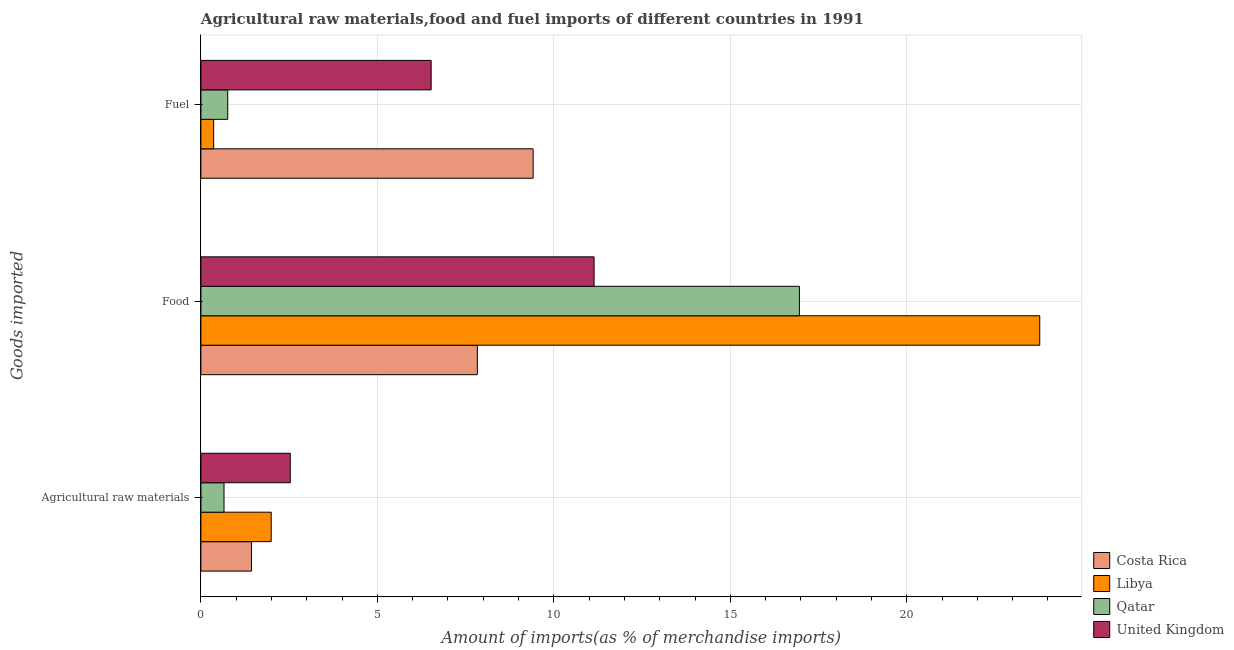How many groups of bars are there?
Your response must be concise. 3. What is the label of the 3rd group of bars from the top?
Give a very brief answer. Agricultural raw materials. What is the percentage of raw materials imports in United Kingdom?
Provide a short and direct response. 2.53. Across all countries, what is the maximum percentage of fuel imports?
Your answer should be very brief. 9.41. Across all countries, what is the minimum percentage of raw materials imports?
Give a very brief answer. 0.65. In which country was the percentage of fuel imports minimum?
Offer a very short reply. Libya. What is the total percentage of raw materials imports in the graph?
Offer a terse response. 6.61. What is the difference between the percentage of fuel imports in United Kingdom and that in Costa Rica?
Offer a terse response. -2.89. What is the difference between the percentage of fuel imports in Costa Rica and the percentage of food imports in Libya?
Offer a very short reply. -14.35. What is the average percentage of fuel imports per country?
Provide a succinct answer. 4.26. What is the difference between the percentage of fuel imports and percentage of raw materials imports in Costa Rica?
Provide a short and direct response. 7.98. In how many countries, is the percentage of food imports greater than 6 %?
Provide a short and direct response. 4. What is the ratio of the percentage of fuel imports in United Kingdom to that in Libya?
Your response must be concise. 18.08. Is the percentage of food imports in Costa Rica less than that in Libya?
Offer a terse response. Yes. What is the difference between the highest and the second highest percentage of fuel imports?
Keep it short and to the point. 2.89. What is the difference between the highest and the lowest percentage of fuel imports?
Provide a short and direct response. 9.05. What does the 1st bar from the bottom in Fuel represents?
Ensure brevity in your answer.  Costa Rica. Is it the case that in every country, the sum of the percentage of raw materials imports and percentage of food imports is greater than the percentage of fuel imports?
Keep it short and to the point. No. How many bars are there?
Your answer should be very brief. 12. How many countries are there in the graph?
Offer a terse response. 4. What is the difference between two consecutive major ticks on the X-axis?
Ensure brevity in your answer.  5. Are the values on the major ticks of X-axis written in scientific E-notation?
Your answer should be very brief. No. Does the graph contain any zero values?
Your response must be concise. No. Does the graph contain grids?
Your answer should be very brief. Yes. How are the legend labels stacked?
Provide a succinct answer. Vertical. What is the title of the graph?
Your answer should be compact. Agricultural raw materials,food and fuel imports of different countries in 1991. Does "Barbados" appear as one of the legend labels in the graph?
Make the answer very short. No. What is the label or title of the X-axis?
Keep it short and to the point. Amount of imports(as % of merchandise imports). What is the label or title of the Y-axis?
Ensure brevity in your answer.  Goods imported. What is the Amount of imports(as % of merchandise imports) in Costa Rica in Agricultural raw materials?
Offer a very short reply. 1.43. What is the Amount of imports(as % of merchandise imports) of Libya in Agricultural raw materials?
Offer a very short reply. 1.99. What is the Amount of imports(as % of merchandise imports) of Qatar in Agricultural raw materials?
Your answer should be very brief. 0.65. What is the Amount of imports(as % of merchandise imports) in United Kingdom in Agricultural raw materials?
Your answer should be compact. 2.53. What is the Amount of imports(as % of merchandise imports) in Costa Rica in Food?
Your answer should be compact. 7.83. What is the Amount of imports(as % of merchandise imports) in Libya in Food?
Your answer should be compact. 23.77. What is the Amount of imports(as % of merchandise imports) of Qatar in Food?
Your answer should be compact. 16.96. What is the Amount of imports(as % of merchandise imports) of United Kingdom in Food?
Your answer should be compact. 11.14. What is the Amount of imports(as % of merchandise imports) of Costa Rica in Fuel?
Provide a short and direct response. 9.41. What is the Amount of imports(as % of merchandise imports) of Libya in Fuel?
Your answer should be compact. 0.36. What is the Amount of imports(as % of merchandise imports) of Qatar in Fuel?
Offer a terse response. 0.76. What is the Amount of imports(as % of merchandise imports) of United Kingdom in Fuel?
Provide a succinct answer. 6.52. Across all Goods imported, what is the maximum Amount of imports(as % of merchandise imports) in Costa Rica?
Keep it short and to the point. 9.41. Across all Goods imported, what is the maximum Amount of imports(as % of merchandise imports) in Libya?
Make the answer very short. 23.77. Across all Goods imported, what is the maximum Amount of imports(as % of merchandise imports) in Qatar?
Provide a succinct answer. 16.96. Across all Goods imported, what is the maximum Amount of imports(as % of merchandise imports) in United Kingdom?
Your response must be concise. 11.14. Across all Goods imported, what is the minimum Amount of imports(as % of merchandise imports) in Costa Rica?
Your answer should be very brief. 1.43. Across all Goods imported, what is the minimum Amount of imports(as % of merchandise imports) in Libya?
Provide a succinct answer. 0.36. Across all Goods imported, what is the minimum Amount of imports(as % of merchandise imports) of Qatar?
Keep it short and to the point. 0.65. Across all Goods imported, what is the minimum Amount of imports(as % of merchandise imports) of United Kingdom?
Ensure brevity in your answer.  2.53. What is the total Amount of imports(as % of merchandise imports) of Costa Rica in the graph?
Your answer should be compact. 18.68. What is the total Amount of imports(as % of merchandise imports) of Libya in the graph?
Offer a very short reply. 26.12. What is the total Amount of imports(as % of merchandise imports) of Qatar in the graph?
Keep it short and to the point. 18.37. What is the total Amount of imports(as % of merchandise imports) in United Kingdom in the graph?
Provide a short and direct response. 20.19. What is the difference between the Amount of imports(as % of merchandise imports) in Costa Rica in Agricultural raw materials and that in Food?
Offer a very short reply. -6.4. What is the difference between the Amount of imports(as % of merchandise imports) in Libya in Agricultural raw materials and that in Food?
Offer a very short reply. -21.78. What is the difference between the Amount of imports(as % of merchandise imports) of Qatar in Agricultural raw materials and that in Food?
Give a very brief answer. -16.3. What is the difference between the Amount of imports(as % of merchandise imports) in United Kingdom in Agricultural raw materials and that in Food?
Your response must be concise. -8.61. What is the difference between the Amount of imports(as % of merchandise imports) in Costa Rica in Agricultural raw materials and that in Fuel?
Your answer should be very brief. -7.98. What is the difference between the Amount of imports(as % of merchandise imports) of Libya in Agricultural raw materials and that in Fuel?
Your answer should be compact. 1.63. What is the difference between the Amount of imports(as % of merchandise imports) in Qatar in Agricultural raw materials and that in Fuel?
Ensure brevity in your answer.  -0.11. What is the difference between the Amount of imports(as % of merchandise imports) in United Kingdom in Agricultural raw materials and that in Fuel?
Your answer should be compact. -3.99. What is the difference between the Amount of imports(as % of merchandise imports) in Costa Rica in Food and that in Fuel?
Offer a terse response. -1.58. What is the difference between the Amount of imports(as % of merchandise imports) in Libya in Food and that in Fuel?
Keep it short and to the point. 23.41. What is the difference between the Amount of imports(as % of merchandise imports) of Qatar in Food and that in Fuel?
Provide a succinct answer. 16.2. What is the difference between the Amount of imports(as % of merchandise imports) of United Kingdom in Food and that in Fuel?
Keep it short and to the point. 4.62. What is the difference between the Amount of imports(as % of merchandise imports) in Costa Rica in Agricultural raw materials and the Amount of imports(as % of merchandise imports) in Libya in Food?
Offer a very short reply. -22.34. What is the difference between the Amount of imports(as % of merchandise imports) in Costa Rica in Agricultural raw materials and the Amount of imports(as % of merchandise imports) in Qatar in Food?
Provide a succinct answer. -15.53. What is the difference between the Amount of imports(as % of merchandise imports) of Costa Rica in Agricultural raw materials and the Amount of imports(as % of merchandise imports) of United Kingdom in Food?
Your response must be concise. -9.71. What is the difference between the Amount of imports(as % of merchandise imports) in Libya in Agricultural raw materials and the Amount of imports(as % of merchandise imports) in Qatar in Food?
Keep it short and to the point. -14.97. What is the difference between the Amount of imports(as % of merchandise imports) in Libya in Agricultural raw materials and the Amount of imports(as % of merchandise imports) in United Kingdom in Food?
Ensure brevity in your answer.  -9.15. What is the difference between the Amount of imports(as % of merchandise imports) in Qatar in Agricultural raw materials and the Amount of imports(as % of merchandise imports) in United Kingdom in Food?
Ensure brevity in your answer.  -10.49. What is the difference between the Amount of imports(as % of merchandise imports) in Costa Rica in Agricultural raw materials and the Amount of imports(as % of merchandise imports) in Libya in Fuel?
Offer a very short reply. 1.07. What is the difference between the Amount of imports(as % of merchandise imports) in Costa Rica in Agricultural raw materials and the Amount of imports(as % of merchandise imports) in Qatar in Fuel?
Your answer should be compact. 0.67. What is the difference between the Amount of imports(as % of merchandise imports) in Costa Rica in Agricultural raw materials and the Amount of imports(as % of merchandise imports) in United Kingdom in Fuel?
Provide a succinct answer. -5.09. What is the difference between the Amount of imports(as % of merchandise imports) of Libya in Agricultural raw materials and the Amount of imports(as % of merchandise imports) of Qatar in Fuel?
Ensure brevity in your answer.  1.23. What is the difference between the Amount of imports(as % of merchandise imports) of Libya in Agricultural raw materials and the Amount of imports(as % of merchandise imports) of United Kingdom in Fuel?
Keep it short and to the point. -4.53. What is the difference between the Amount of imports(as % of merchandise imports) of Qatar in Agricultural raw materials and the Amount of imports(as % of merchandise imports) of United Kingdom in Fuel?
Your response must be concise. -5.87. What is the difference between the Amount of imports(as % of merchandise imports) of Costa Rica in Food and the Amount of imports(as % of merchandise imports) of Libya in Fuel?
Provide a short and direct response. 7.47. What is the difference between the Amount of imports(as % of merchandise imports) of Costa Rica in Food and the Amount of imports(as % of merchandise imports) of Qatar in Fuel?
Your response must be concise. 7.07. What is the difference between the Amount of imports(as % of merchandise imports) of Costa Rica in Food and the Amount of imports(as % of merchandise imports) of United Kingdom in Fuel?
Ensure brevity in your answer.  1.31. What is the difference between the Amount of imports(as % of merchandise imports) of Libya in Food and the Amount of imports(as % of merchandise imports) of Qatar in Fuel?
Offer a terse response. 23.01. What is the difference between the Amount of imports(as % of merchandise imports) in Libya in Food and the Amount of imports(as % of merchandise imports) in United Kingdom in Fuel?
Your answer should be compact. 17.24. What is the difference between the Amount of imports(as % of merchandise imports) of Qatar in Food and the Amount of imports(as % of merchandise imports) of United Kingdom in Fuel?
Ensure brevity in your answer.  10.43. What is the average Amount of imports(as % of merchandise imports) in Costa Rica per Goods imported?
Your answer should be compact. 6.23. What is the average Amount of imports(as % of merchandise imports) of Libya per Goods imported?
Ensure brevity in your answer.  8.71. What is the average Amount of imports(as % of merchandise imports) of Qatar per Goods imported?
Offer a very short reply. 6.12. What is the average Amount of imports(as % of merchandise imports) of United Kingdom per Goods imported?
Provide a short and direct response. 6.73. What is the difference between the Amount of imports(as % of merchandise imports) in Costa Rica and Amount of imports(as % of merchandise imports) in Libya in Agricultural raw materials?
Your answer should be compact. -0.56. What is the difference between the Amount of imports(as % of merchandise imports) in Costa Rica and Amount of imports(as % of merchandise imports) in Qatar in Agricultural raw materials?
Your answer should be compact. 0.78. What is the difference between the Amount of imports(as % of merchandise imports) of Costa Rica and Amount of imports(as % of merchandise imports) of United Kingdom in Agricultural raw materials?
Provide a short and direct response. -1.1. What is the difference between the Amount of imports(as % of merchandise imports) in Libya and Amount of imports(as % of merchandise imports) in Qatar in Agricultural raw materials?
Keep it short and to the point. 1.34. What is the difference between the Amount of imports(as % of merchandise imports) in Libya and Amount of imports(as % of merchandise imports) in United Kingdom in Agricultural raw materials?
Offer a terse response. -0.54. What is the difference between the Amount of imports(as % of merchandise imports) of Qatar and Amount of imports(as % of merchandise imports) of United Kingdom in Agricultural raw materials?
Provide a short and direct response. -1.88. What is the difference between the Amount of imports(as % of merchandise imports) in Costa Rica and Amount of imports(as % of merchandise imports) in Libya in Food?
Offer a very short reply. -15.94. What is the difference between the Amount of imports(as % of merchandise imports) of Costa Rica and Amount of imports(as % of merchandise imports) of Qatar in Food?
Provide a short and direct response. -9.12. What is the difference between the Amount of imports(as % of merchandise imports) in Costa Rica and Amount of imports(as % of merchandise imports) in United Kingdom in Food?
Offer a terse response. -3.31. What is the difference between the Amount of imports(as % of merchandise imports) in Libya and Amount of imports(as % of merchandise imports) in Qatar in Food?
Provide a short and direct response. 6.81. What is the difference between the Amount of imports(as % of merchandise imports) in Libya and Amount of imports(as % of merchandise imports) in United Kingdom in Food?
Provide a short and direct response. 12.63. What is the difference between the Amount of imports(as % of merchandise imports) of Qatar and Amount of imports(as % of merchandise imports) of United Kingdom in Food?
Offer a terse response. 5.82. What is the difference between the Amount of imports(as % of merchandise imports) in Costa Rica and Amount of imports(as % of merchandise imports) in Libya in Fuel?
Ensure brevity in your answer.  9.05. What is the difference between the Amount of imports(as % of merchandise imports) in Costa Rica and Amount of imports(as % of merchandise imports) in Qatar in Fuel?
Your answer should be compact. 8.65. What is the difference between the Amount of imports(as % of merchandise imports) in Costa Rica and Amount of imports(as % of merchandise imports) in United Kingdom in Fuel?
Make the answer very short. 2.89. What is the difference between the Amount of imports(as % of merchandise imports) of Libya and Amount of imports(as % of merchandise imports) of Qatar in Fuel?
Your answer should be compact. -0.4. What is the difference between the Amount of imports(as % of merchandise imports) of Libya and Amount of imports(as % of merchandise imports) of United Kingdom in Fuel?
Ensure brevity in your answer.  -6.16. What is the difference between the Amount of imports(as % of merchandise imports) of Qatar and Amount of imports(as % of merchandise imports) of United Kingdom in Fuel?
Ensure brevity in your answer.  -5.76. What is the ratio of the Amount of imports(as % of merchandise imports) of Costa Rica in Agricultural raw materials to that in Food?
Ensure brevity in your answer.  0.18. What is the ratio of the Amount of imports(as % of merchandise imports) of Libya in Agricultural raw materials to that in Food?
Your response must be concise. 0.08. What is the ratio of the Amount of imports(as % of merchandise imports) of Qatar in Agricultural raw materials to that in Food?
Ensure brevity in your answer.  0.04. What is the ratio of the Amount of imports(as % of merchandise imports) of United Kingdom in Agricultural raw materials to that in Food?
Give a very brief answer. 0.23. What is the ratio of the Amount of imports(as % of merchandise imports) of Costa Rica in Agricultural raw materials to that in Fuel?
Give a very brief answer. 0.15. What is the ratio of the Amount of imports(as % of merchandise imports) in Libya in Agricultural raw materials to that in Fuel?
Your answer should be very brief. 5.52. What is the ratio of the Amount of imports(as % of merchandise imports) of Qatar in Agricultural raw materials to that in Fuel?
Provide a short and direct response. 0.86. What is the ratio of the Amount of imports(as % of merchandise imports) in United Kingdom in Agricultural raw materials to that in Fuel?
Provide a succinct answer. 0.39. What is the ratio of the Amount of imports(as % of merchandise imports) of Costa Rica in Food to that in Fuel?
Offer a terse response. 0.83. What is the ratio of the Amount of imports(as % of merchandise imports) in Libya in Food to that in Fuel?
Keep it short and to the point. 65.88. What is the ratio of the Amount of imports(as % of merchandise imports) in Qatar in Food to that in Fuel?
Offer a terse response. 22.33. What is the ratio of the Amount of imports(as % of merchandise imports) in United Kingdom in Food to that in Fuel?
Give a very brief answer. 1.71. What is the difference between the highest and the second highest Amount of imports(as % of merchandise imports) in Costa Rica?
Make the answer very short. 1.58. What is the difference between the highest and the second highest Amount of imports(as % of merchandise imports) in Libya?
Offer a very short reply. 21.78. What is the difference between the highest and the second highest Amount of imports(as % of merchandise imports) in Qatar?
Provide a succinct answer. 16.2. What is the difference between the highest and the second highest Amount of imports(as % of merchandise imports) of United Kingdom?
Keep it short and to the point. 4.62. What is the difference between the highest and the lowest Amount of imports(as % of merchandise imports) in Costa Rica?
Give a very brief answer. 7.98. What is the difference between the highest and the lowest Amount of imports(as % of merchandise imports) in Libya?
Ensure brevity in your answer.  23.41. What is the difference between the highest and the lowest Amount of imports(as % of merchandise imports) of Qatar?
Give a very brief answer. 16.3. What is the difference between the highest and the lowest Amount of imports(as % of merchandise imports) of United Kingdom?
Give a very brief answer. 8.61. 